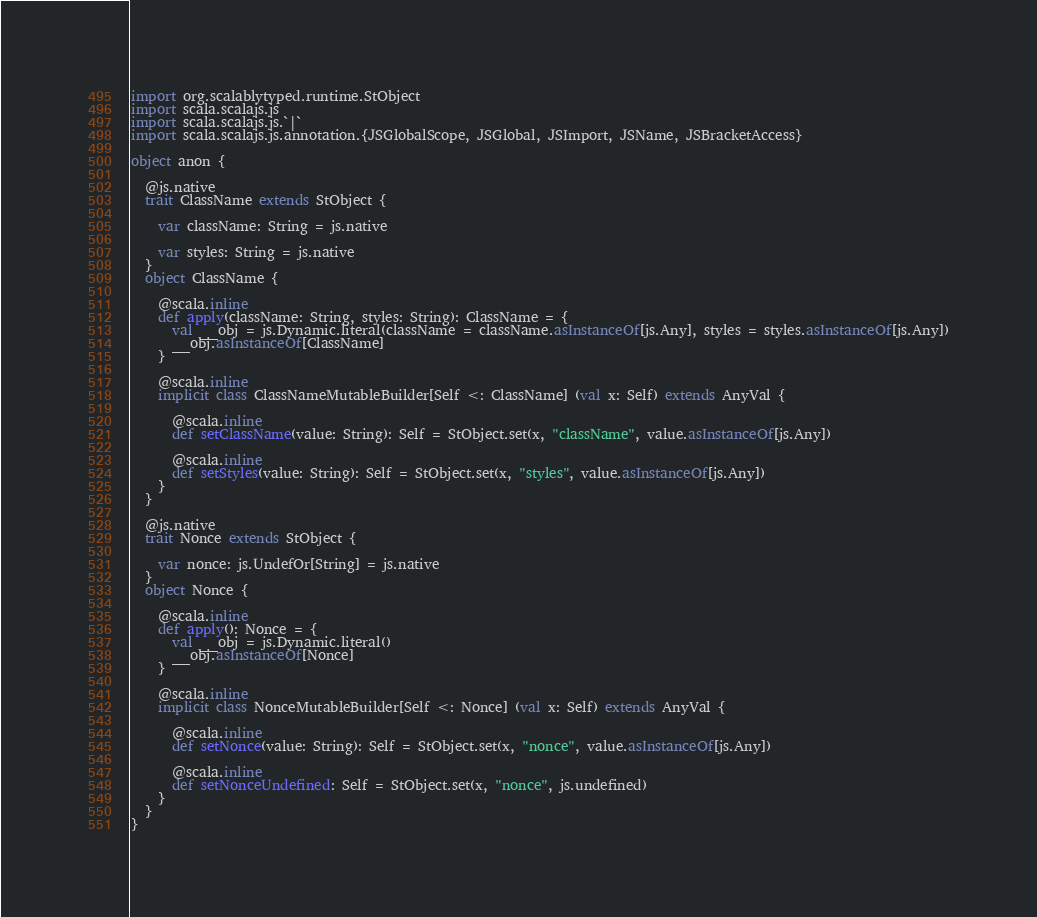Convert code to text. <code><loc_0><loc_0><loc_500><loc_500><_Scala_>import org.scalablytyped.runtime.StObject
import scala.scalajs.js
import scala.scalajs.js.`|`
import scala.scalajs.js.annotation.{JSGlobalScope, JSGlobal, JSImport, JSName, JSBracketAccess}

object anon {
  
  @js.native
  trait ClassName extends StObject {
    
    var className: String = js.native
    
    var styles: String = js.native
  }
  object ClassName {
    
    @scala.inline
    def apply(className: String, styles: String): ClassName = {
      val __obj = js.Dynamic.literal(className = className.asInstanceOf[js.Any], styles = styles.asInstanceOf[js.Any])
      __obj.asInstanceOf[ClassName]
    }
    
    @scala.inline
    implicit class ClassNameMutableBuilder[Self <: ClassName] (val x: Self) extends AnyVal {
      
      @scala.inline
      def setClassName(value: String): Self = StObject.set(x, "className", value.asInstanceOf[js.Any])
      
      @scala.inline
      def setStyles(value: String): Self = StObject.set(x, "styles", value.asInstanceOf[js.Any])
    }
  }
  
  @js.native
  trait Nonce extends StObject {
    
    var nonce: js.UndefOr[String] = js.native
  }
  object Nonce {
    
    @scala.inline
    def apply(): Nonce = {
      val __obj = js.Dynamic.literal()
      __obj.asInstanceOf[Nonce]
    }
    
    @scala.inline
    implicit class NonceMutableBuilder[Self <: Nonce] (val x: Self) extends AnyVal {
      
      @scala.inline
      def setNonce(value: String): Self = StObject.set(x, "nonce", value.asInstanceOf[js.Any])
      
      @scala.inline
      def setNonceUndefined: Self = StObject.set(x, "nonce", js.undefined)
    }
  }
}
</code> 